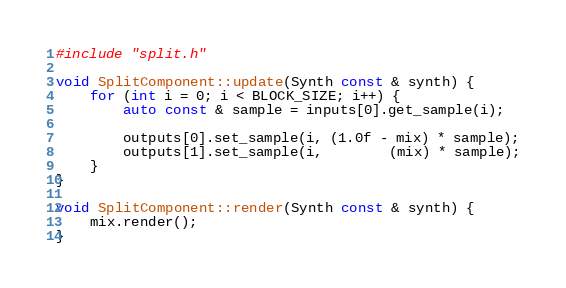Convert code to text. <code><loc_0><loc_0><loc_500><loc_500><_C++_>#include "split.h"

void SplitComponent::update(Synth const & synth) {
	for (int i = 0; i < BLOCK_SIZE; i++) {
		auto const & sample = inputs[0].get_sample(i);

		outputs[0].set_sample(i, (1.0f - mix) * sample);
		outputs[1].set_sample(i,        (mix) * sample);
	}
}

void SplitComponent::render(Synth const & synth) {
	mix.render();
}
</code> 